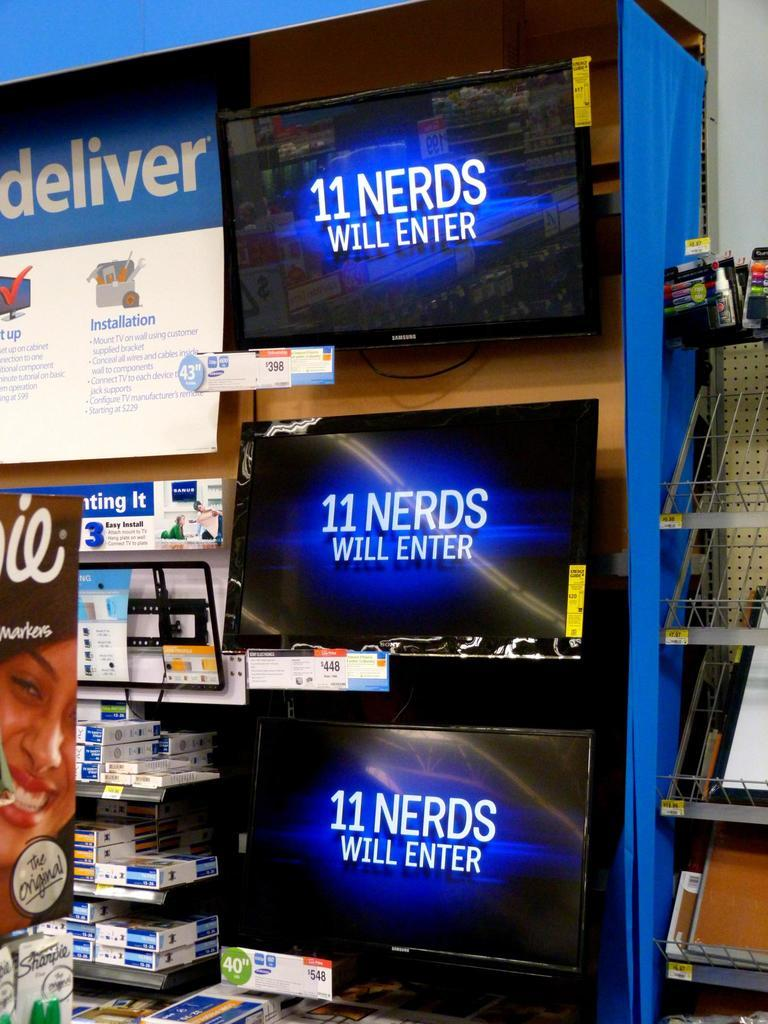Provide a one-sentence caption for the provided image. Three screens display the message "11 nerds will enter.". 